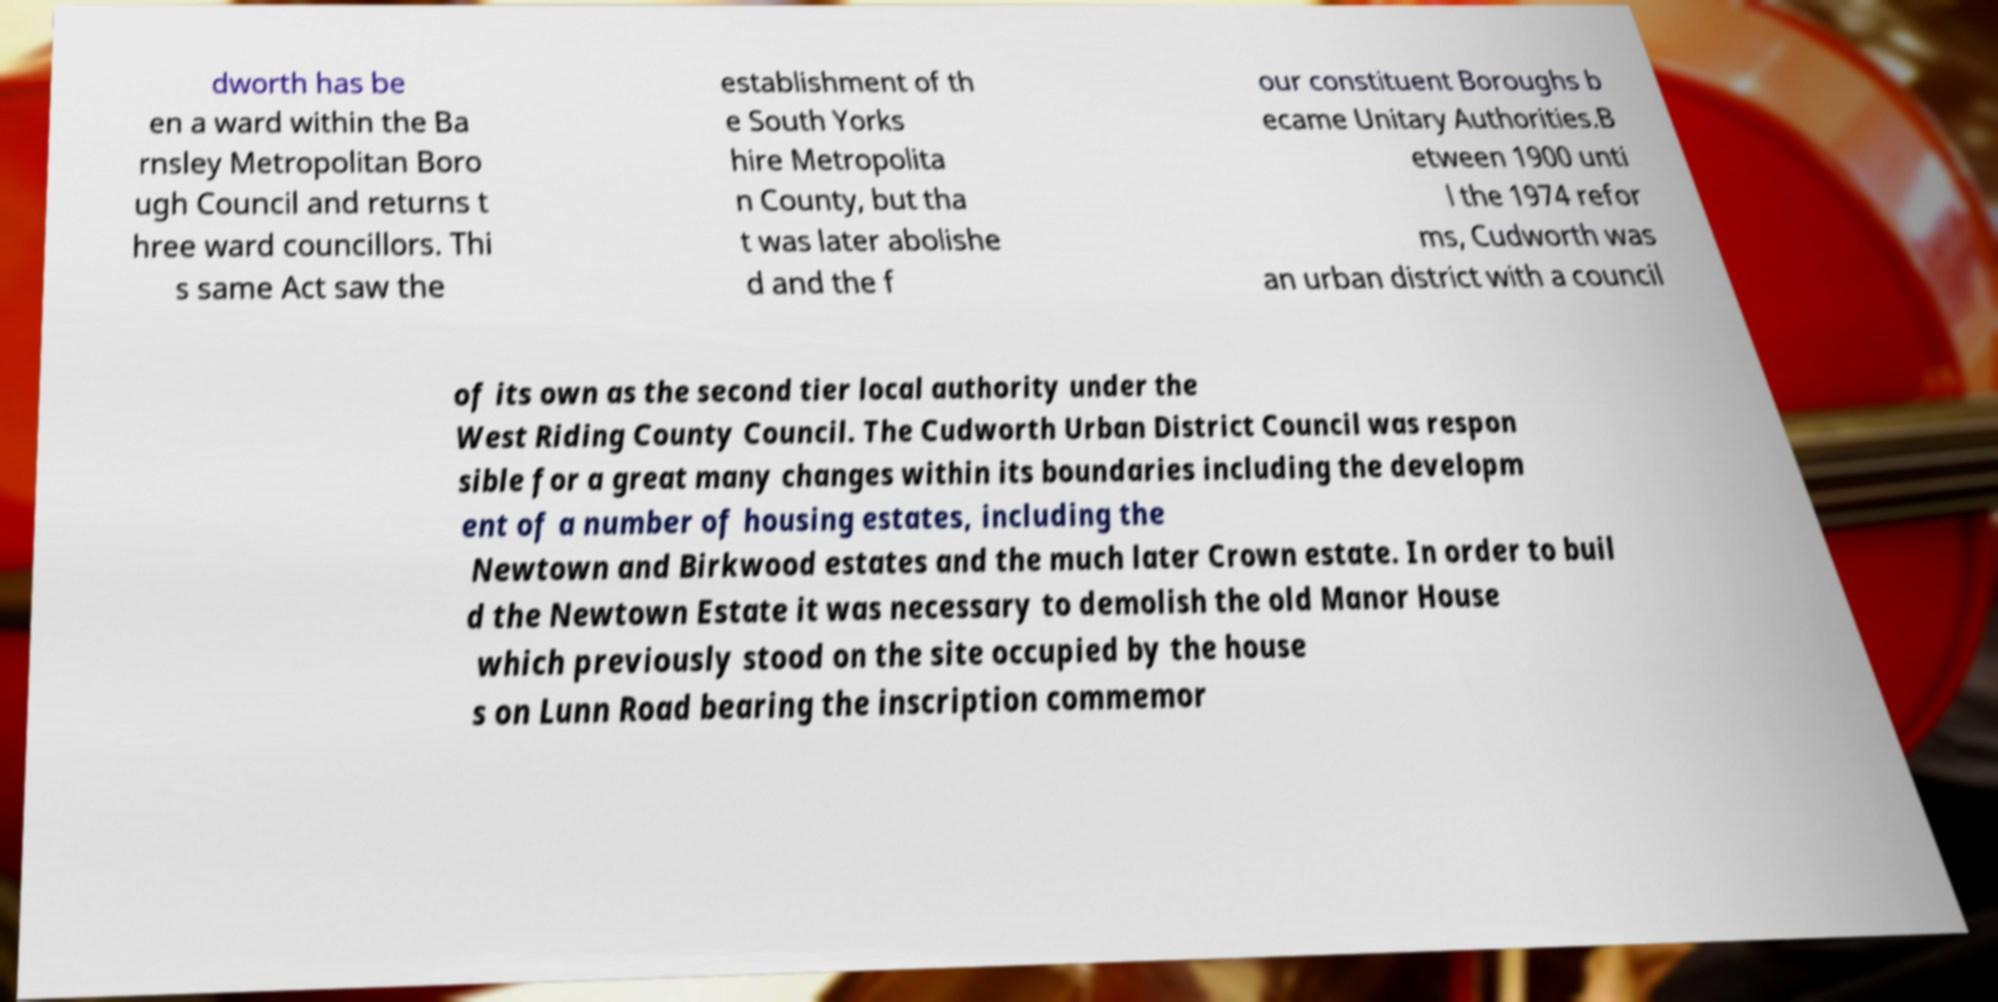Please identify and transcribe the text found in this image. dworth has be en a ward within the Ba rnsley Metropolitan Boro ugh Council and returns t hree ward councillors. Thi s same Act saw the establishment of th e South Yorks hire Metropolita n County, but tha t was later abolishe d and the f our constituent Boroughs b ecame Unitary Authorities.B etween 1900 unti l the 1974 refor ms, Cudworth was an urban district with a council of its own as the second tier local authority under the West Riding County Council. The Cudworth Urban District Council was respon sible for a great many changes within its boundaries including the developm ent of a number of housing estates, including the Newtown and Birkwood estates and the much later Crown estate. In order to buil d the Newtown Estate it was necessary to demolish the old Manor House which previously stood on the site occupied by the house s on Lunn Road bearing the inscription commemor 